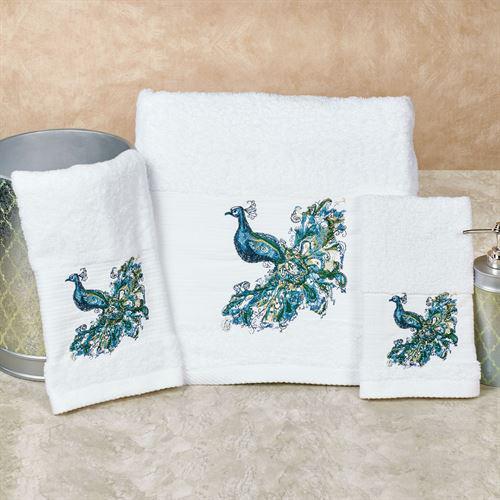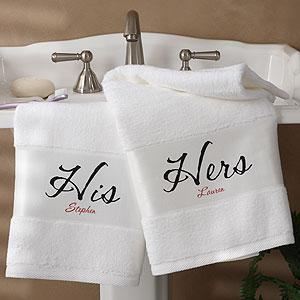The first image is the image on the left, the second image is the image on the right. Given the left and right images, does the statement "There are three towels with birds on them in one of the images." hold true? Answer yes or no. Yes. The first image is the image on the left, the second image is the image on the right. For the images displayed, is the sentence "Hand towels with birds on them are resting on a counter" factually correct? Answer yes or no. Yes. 